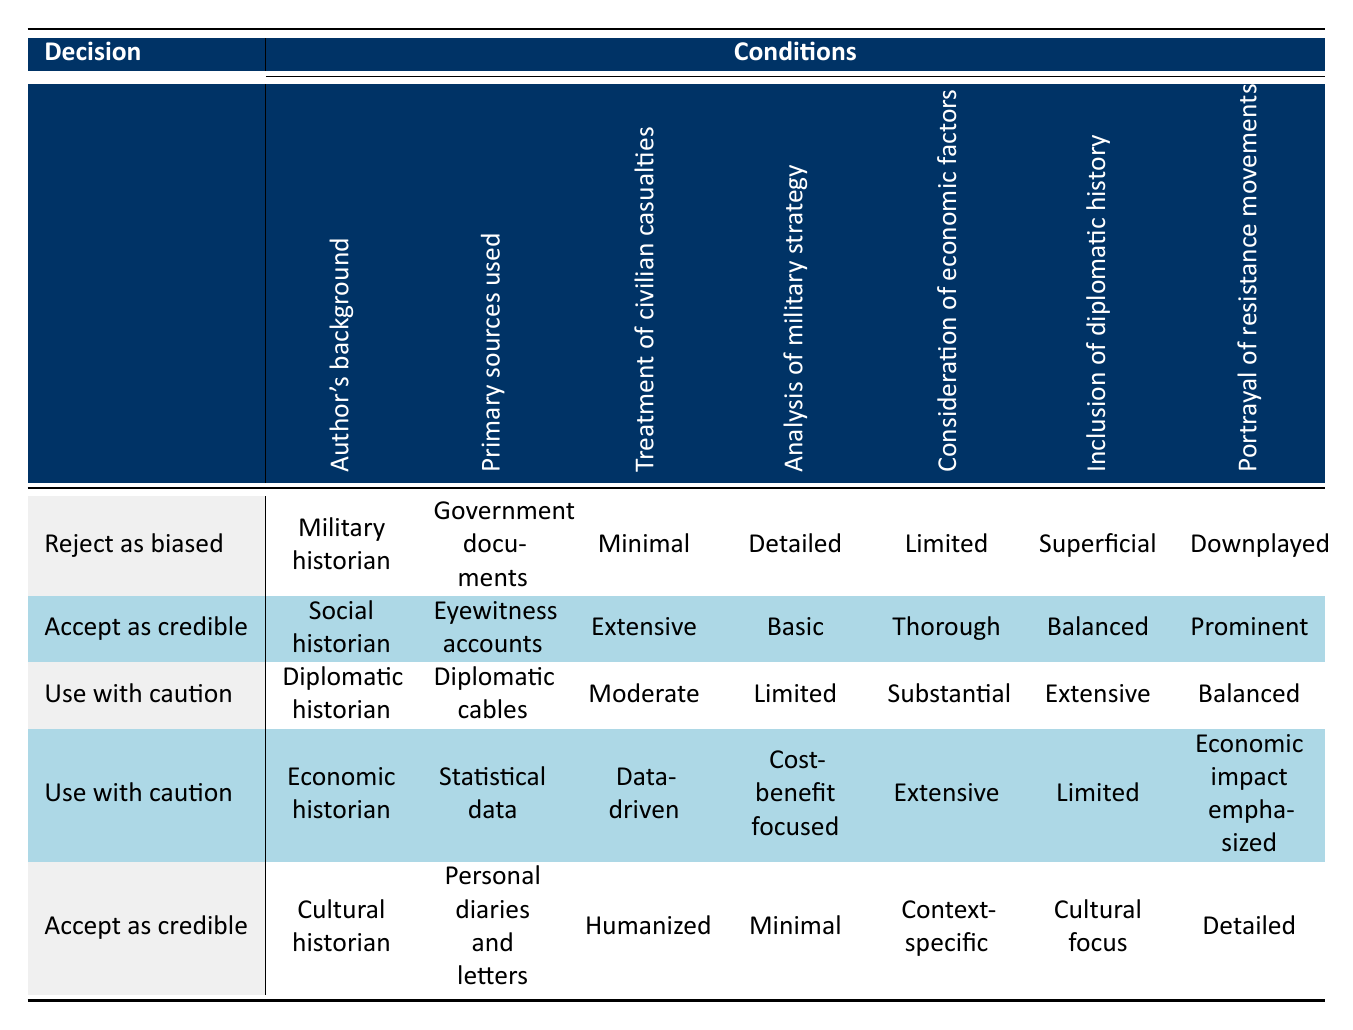What is the decision for a military historian using government documents? The row for the military historian shows the decision as "Reject as biased." This is directly stated in the table and is found by looking at the corresponding criteria in that row.
Answer: Reject as biased Which historian accepts their account as credible when treating civilian casualties extensively? The row for the social historian indicates "Accept as credible" and fulfills the condition of dealing extensively with civilian casualties.
Answer: Social historian How many historians recommend using accounts with caution? There are two rows (diplomatic historian and economic historian) that indicate the decision "Use with caution." Therefore, by counting these rows, we find that two historians recommend this approach.
Answer: 2 What primary sources are used by the cultural historian? The cultural historian is associated with the use of "Personal diaries and letters," which is clearly stated in his corresponding row in the table.
Answer: Personal diaries and letters Does the analysis of military strategy by the economic historian focus on cost-benefit? The economic historian's row states that their analysis of military strategy is "Cost-benefit focused," which is a clear affirmation of this criterion.
Answer: Yes What is the average level of treatment of civilian casualties among the historians listed? The treatment of civilian casualties is categorized as Minimal, Extensive, Data-driven, Humanized, and Moderate. To calculate the average, we assign a value (1 for Minimal, 5 for Extensive, 3 for Moderate, etc.) and then compute the average. The summation is: 1 + 5 + 3 + 4 + 2 = 15, and there are 5 historians, leading to an average of 15/5 = 3.
Answer: 3 Which historian downplays resistance movements while rejecting their account? The military historian's row shows that the portrayal of resistance movements is "Downplayed" and corresponds with the decision to "Reject as biased." This information is captured in their respective row in the table.
Answer: Military historian Is the portrayal of resistance movements emphasized by the diplomatic historian? The diplomatic historian’s row indicates that the portrayal of resistance movements is "Balanced," meaning it does not particularly emphasize or downplay it. Therefore, the answer is no.
Answer: No 